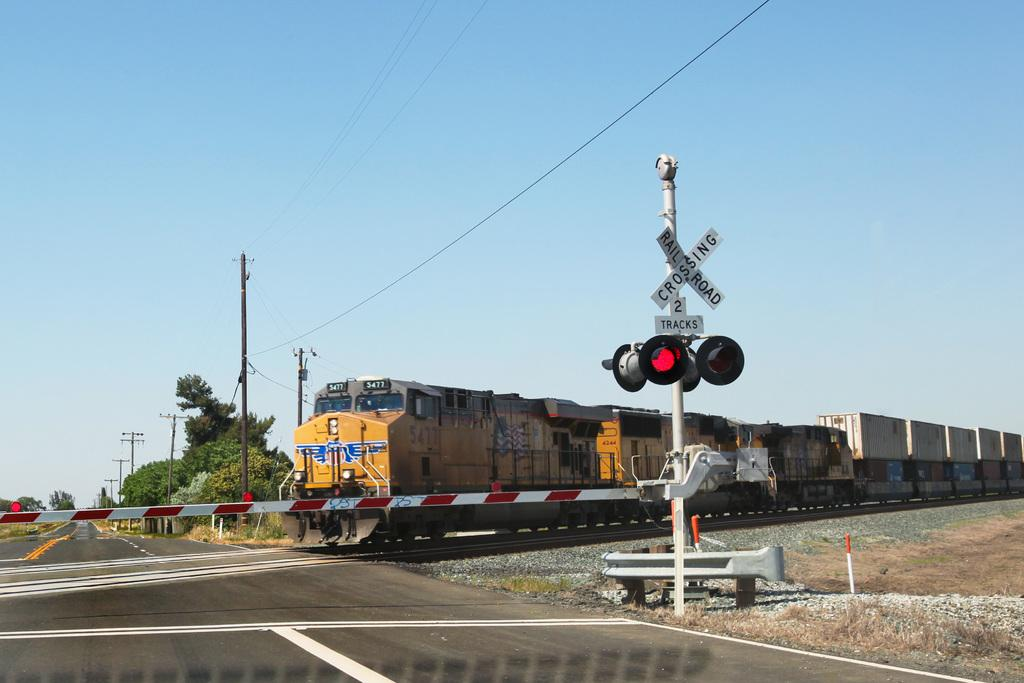<image>
Share a concise interpretation of the image provided. A railroad crossing sign tells drivers that there are 2 tracks here. 